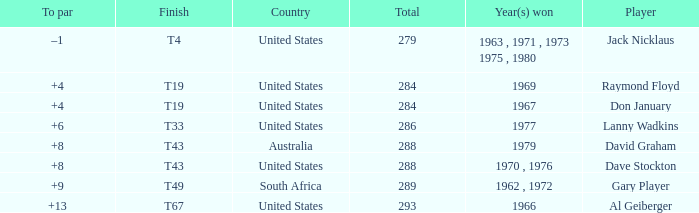What is the average total in 1969? 284.0. 